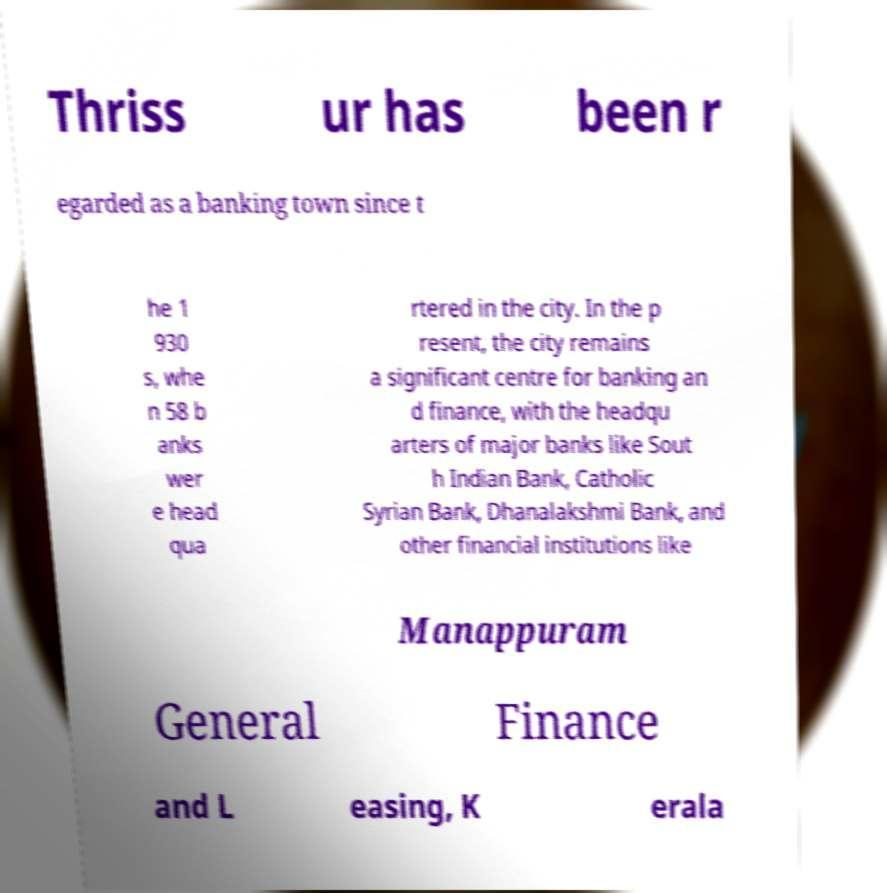Could you extract and type out the text from this image? Thriss ur has been r egarded as a banking town since t he 1 930 s, whe n 58 b anks wer e head qua rtered in the city. In the p resent, the city remains a significant centre for banking an d finance, with the headqu arters of major banks like Sout h Indian Bank, Catholic Syrian Bank, Dhanalakshmi Bank, and other financial institutions like Manappuram General Finance and L easing, K erala 